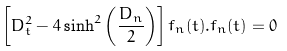Convert formula to latex. <formula><loc_0><loc_0><loc_500><loc_500>\left [ D _ { t } ^ { 2 } - 4 \sinh ^ { 2 } { \left ( \frac { D _ { n } } { 2 } \right ) } \right ] f _ { n } ( t ) . f _ { n } ( t ) = 0</formula> 